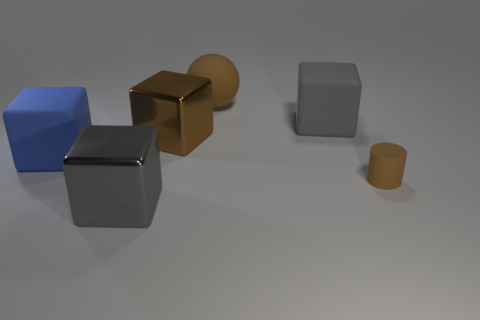Which objects seem to have a reflective surface? The two cubes in the image appear to have reflective surfaces, as indicated by the visible light highlights and the reflections of the environment on their faces. 